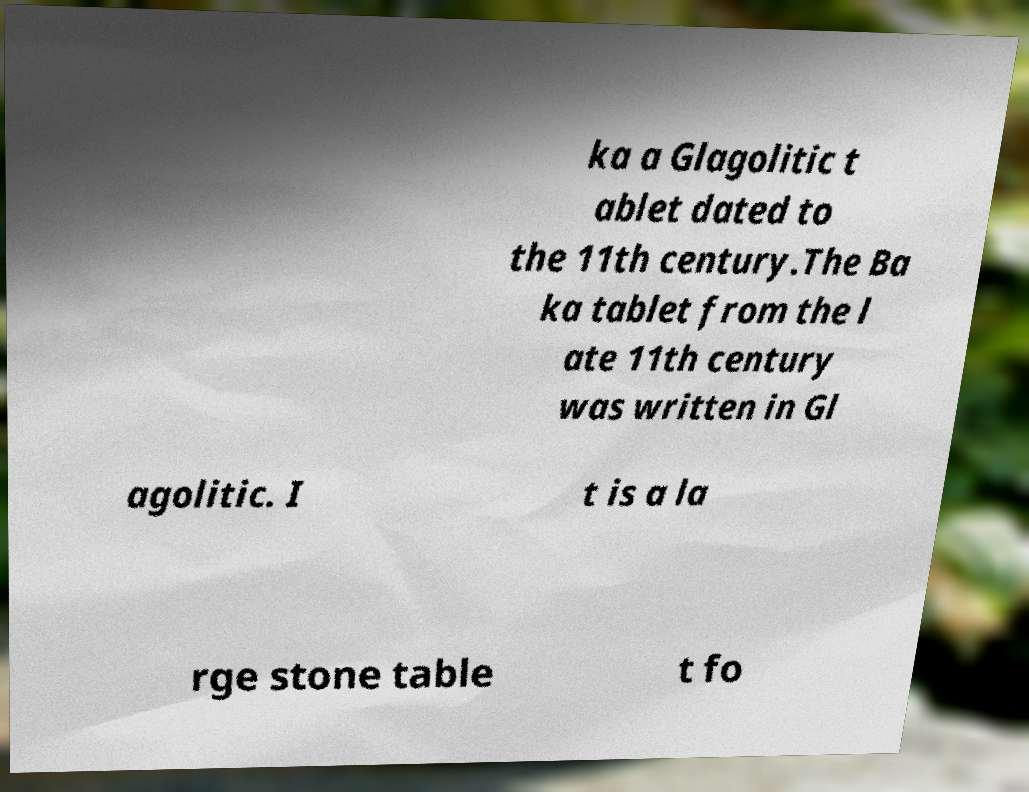I need the written content from this picture converted into text. Can you do that? ka a Glagolitic t ablet dated to the 11th century.The Ba ka tablet from the l ate 11th century was written in Gl agolitic. I t is a la rge stone table t fo 